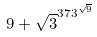<formula> <loc_0><loc_0><loc_500><loc_500>9 + \sqrt { 3 } ^ { 3 7 3 ^ { \sqrt { 9 } } }</formula> 